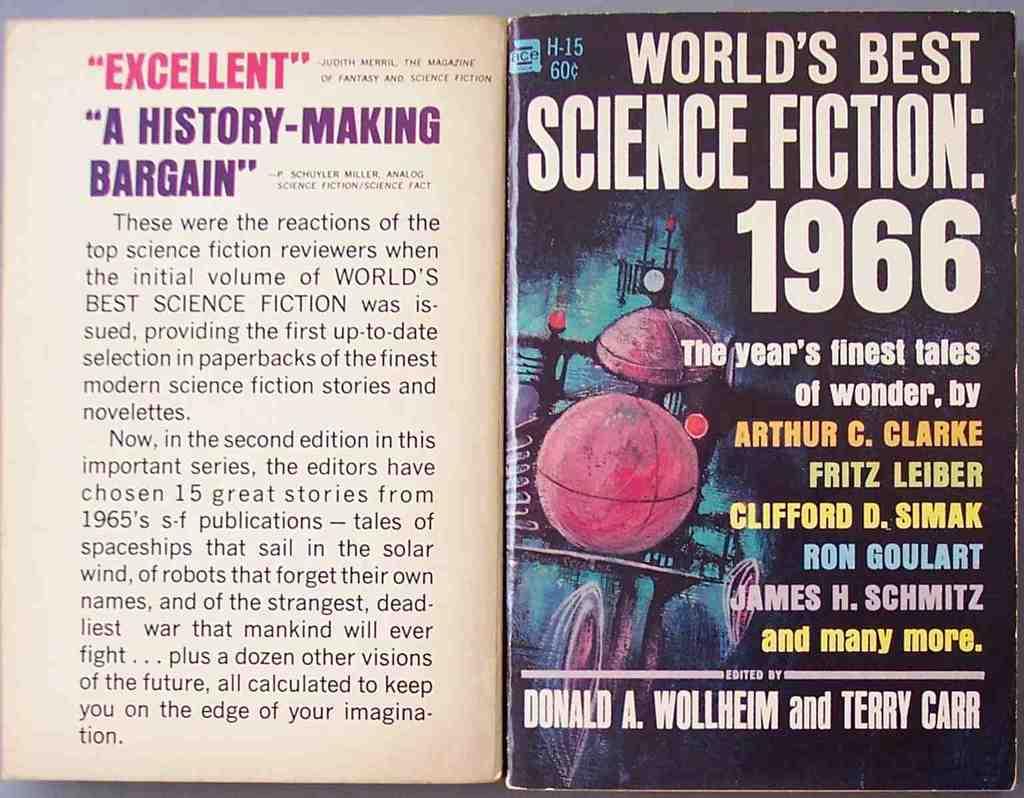Who edited this magazine?
Provide a succinct answer. Donald a. wollheim and terry carr. What year is mentioned on the right page?
Offer a very short reply. 1966. 